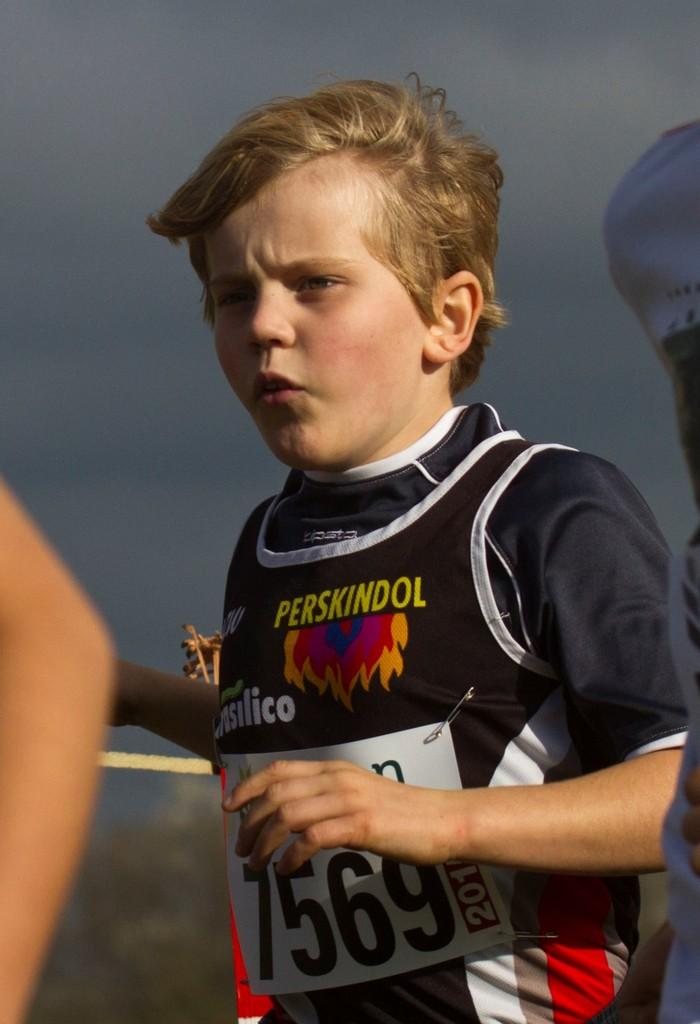<image>
Offer a succinct explanation of the picture presented. A young runner has the number 7569 displayed on his Perskindol jersey. 